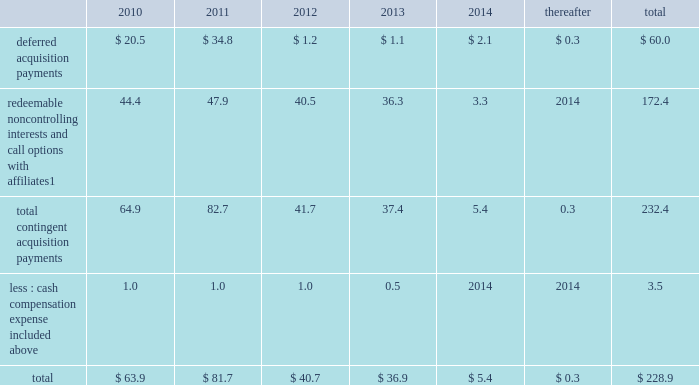Notes to consolidated financial statements 2013 ( continued ) ( amounts in millions , except per share amounts ) guarantees we have guarantees of certain obligations of our subsidiaries relating principally to credit facilities , certain media payables and operating leases of certain subsidiaries .
The amount of such parent company guarantees was $ 769.3 and $ 706.7 as of december 31 , 2009 and 2008 , respectively .
In the event of non-payment by the applicable subsidiary of the obligations covered by a guarantee , we would be obligated to pay the amounts covered by that guarantee .
As of december 31 , 2009 , there are no material assets pledged as security for such parent company guarantees .
Contingent acquisition obligations the table details the estimated future contingent acquisition obligations payable in cash as of december 31 , 2009 .
The estimated amounts listed would be paid in the event of exercise at the earliest exercise date .
See note 6 for further information relating to the payment structure of our acquisitions .
All payments are contingent upon achieving projected operating performance targets and satisfying other conditions specified in the related agreements and are subject to revisions as the earn-out periods progress. .
1 we have entered into certain acquisitions that contain both redeemable noncontrolling interests and call options with similar terms and conditions .
In such instances , we have included the related estimated contingent acquisition obligation in the period when the earliest related option is exercisable .
We have certain redeemable noncontrolling interests that are exercisable at the discretion of the noncontrolling equity owners as of december 31 , 2009 .
As such , these estimated acquisition payments of $ 20.5 have been included within the total payments expected to be made in 2010 in the table and , if not made in 2010 , will continue to carry forward into 2011 or beyond until they are exercised or expire .
Redeemable noncontrolling interests are included in the table at current exercise price payable in cash , not at applicable redemption value in accordance with the authoritative guidance for classification and measurement of redeemable securities .
Legal matters we are involved in legal and administrative proceedings of various types .
While any litigation contains an element of uncertainty , we do not believe that the outcome of such proceedings will have a material adverse effect on our financial condition , results of operations or cash flows .
Note 16 : recent accounting standards in december 2009 , the financial accounting standards board ( 201cfasb 201d ) amended authoritative guidance related to accounting for transfers and servicing of financial assets and extinguishments of liabilities .
The guidance will be effective for the company beginning january 1 , 2010 .
The guidance eliminates the concept of a qualifying special-purpose entity and changes the criteria for derecognizing financial assets .
In addition , the guidance will require additional disclosures related to a company 2019s continued involvement with financial assets that have been transferred .
We do not expect the adoption of this amended guidance to have a significant impact on our consolidated financial statements .
In december 2009 , the fasb amended authoritative guidance for consolidating variable interest entities .
The guidance will be effective for the company beginning january 1 , 2010 .
Specifically , the guidance revises factors that should be considered by a reporting entity when determining whether an entity that is insufficiently capitalized or is not controlled through voting ( or similar rights ) should be consolidated .
This guidance also includes revised financial statement disclosures regarding the reporting entity 2019s involvement , including significant risk exposures as a result of that involvement , and the impact the relationship has on the reporting entity 2019s financial statements .
We are currently evaluating the potential impact of the amended guidance on our consolidated financial statements. .
In 2010 what was percentage of the deferred acquisition payments of the total payments? 
Computations: (20.5 / 63.9)
Answer: 0.32081. 